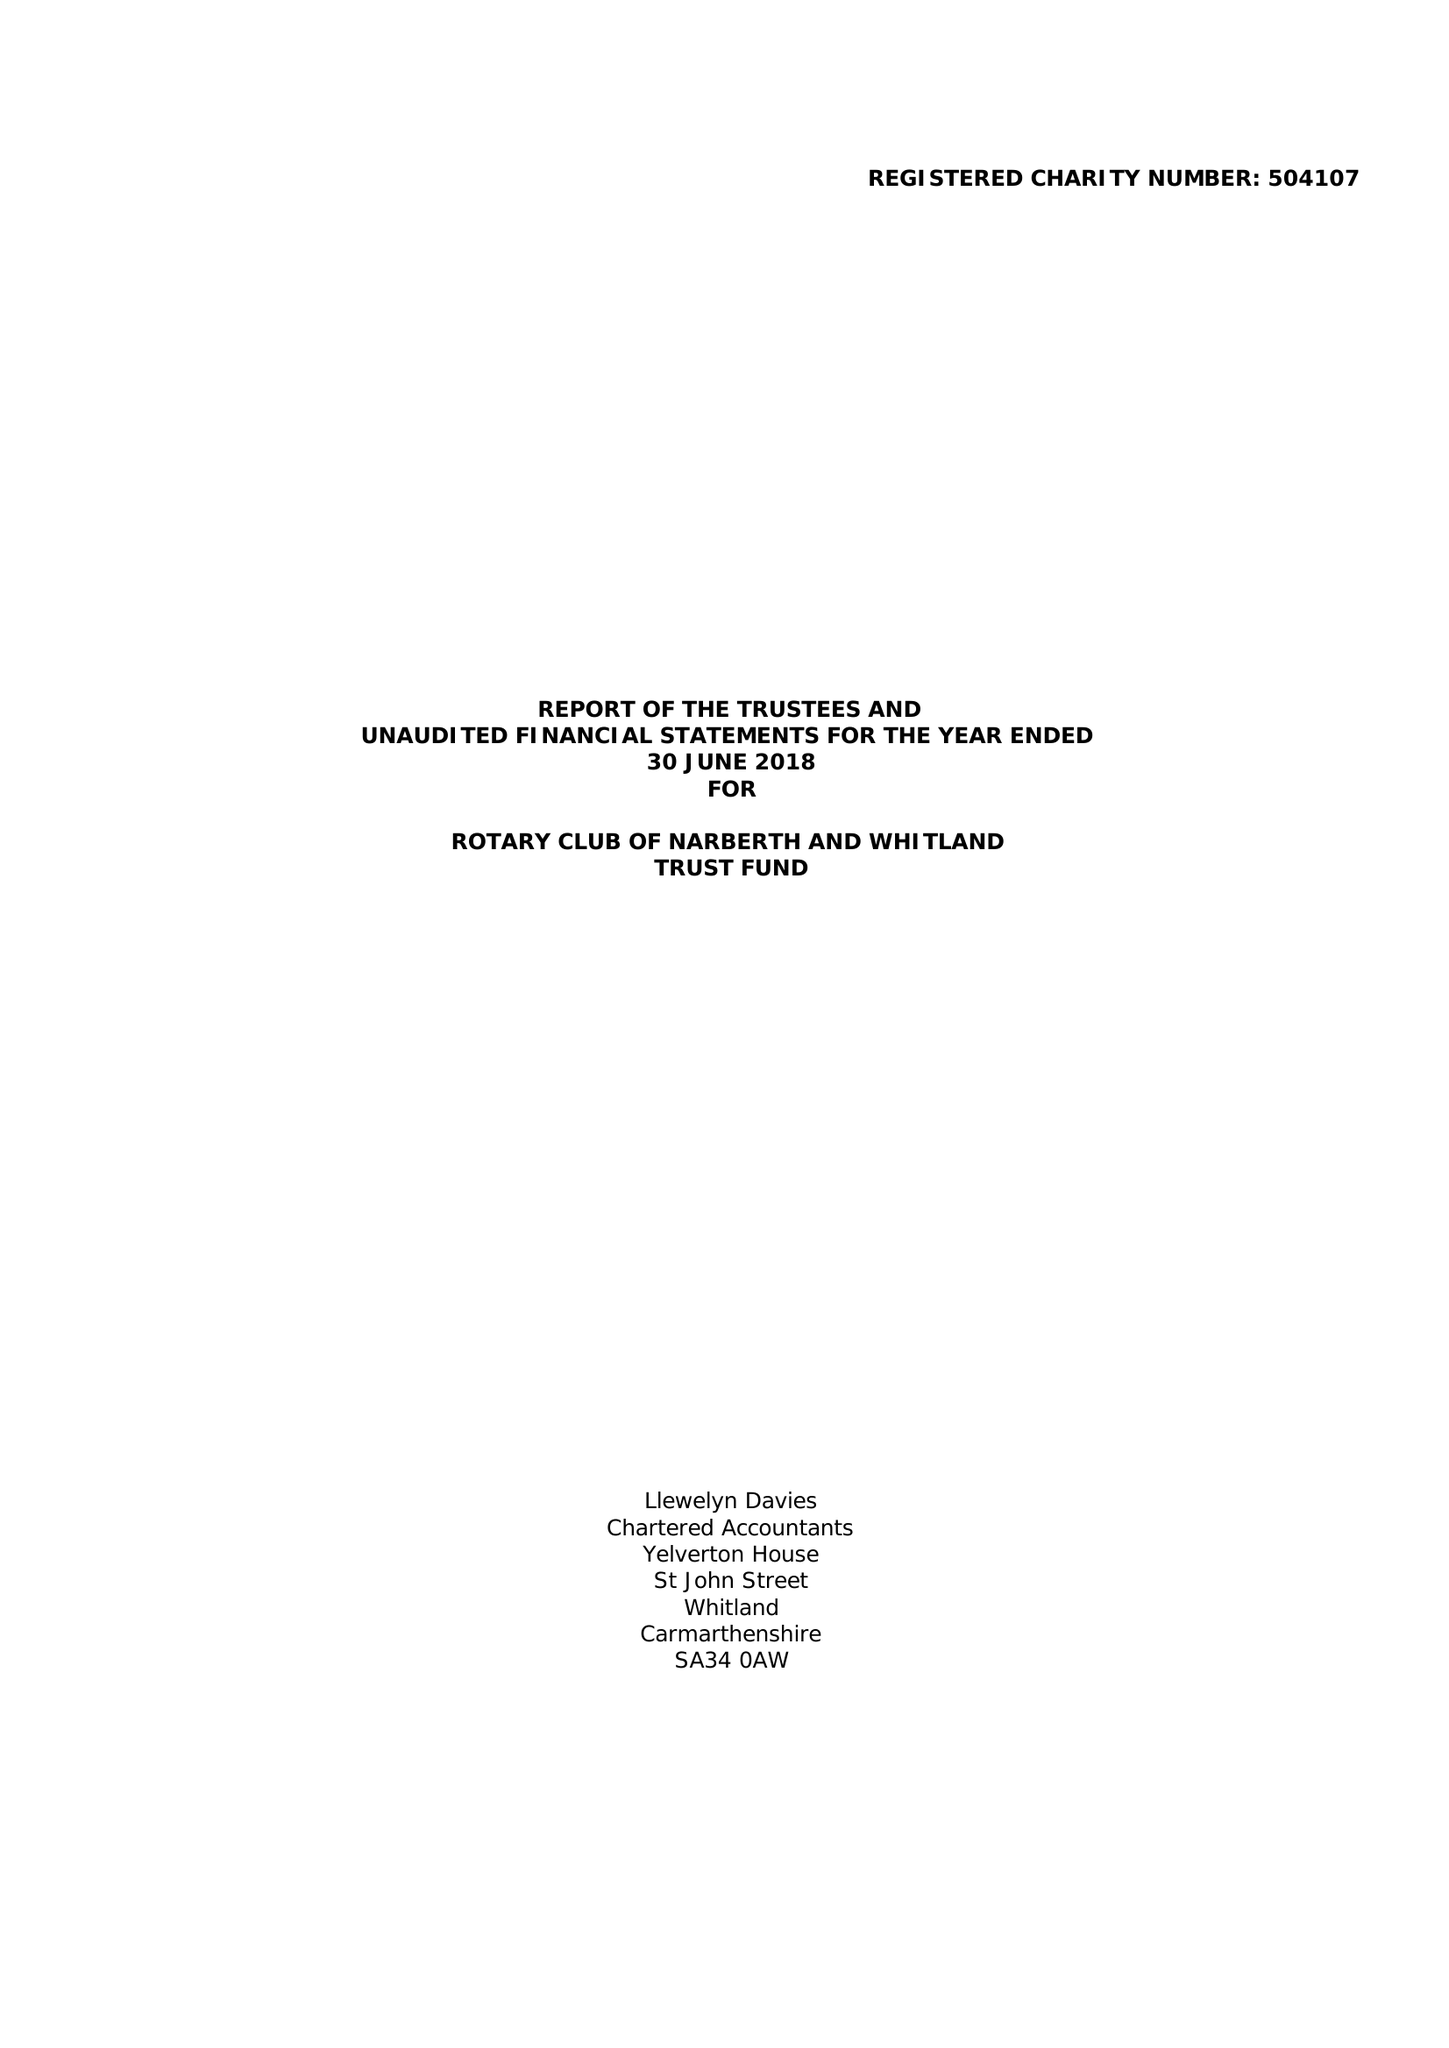What is the value for the income_annually_in_british_pounds?
Answer the question using a single word or phrase. 29076.00 